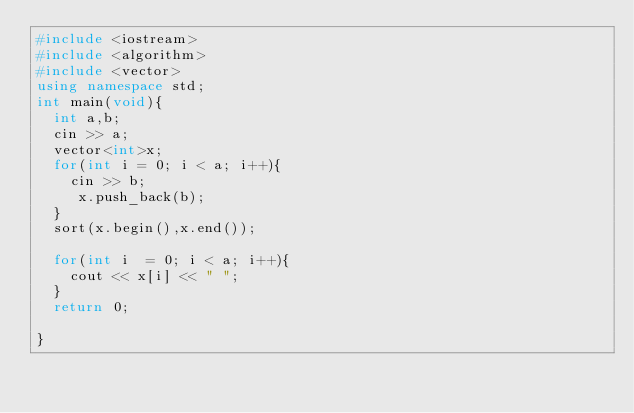<code> <loc_0><loc_0><loc_500><loc_500><_C++_>#include <iostream>
#include <algorithm>
#include <vector>
using namespace std;
int main(void){
  int a,b;
  cin >> a;
  vector<int>x;
  for(int i = 0; i < a; i++){
	cin >> b;
     x.push_back(b);
  }
  sort(x.begin(),x.end());

  for(int i  = 0; i < a; i++){
	cout << x[i] << " ";
  }
  return 0;

}</code> 